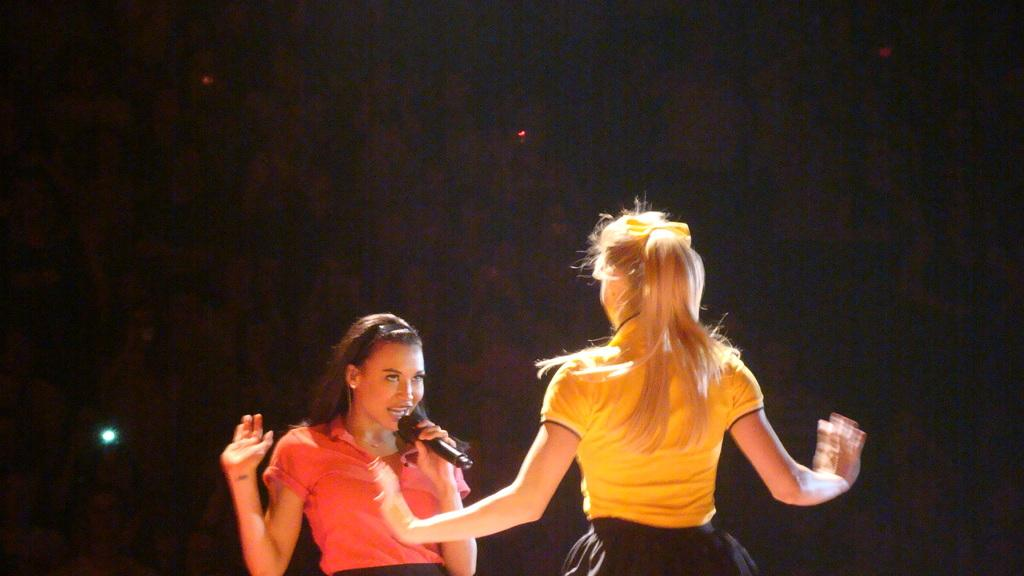How many people are in the image? There are two ladies in the image. What is one of the ladies doing? One of the ladies is holding a mic. What is the lady holding the mic doing? The lady holding the mic is singing. What can be seen in the image besides the ladies? There are lights visible in the image. How would you describe the overall lighting in the image? The background of the image is dark. What type of juice is being served to the ladies in the image? There is no juice present in the image; the ladies are singing and holding a mic. Can you tell me how many planes are visible in the image? There are no planes visible in the image. 